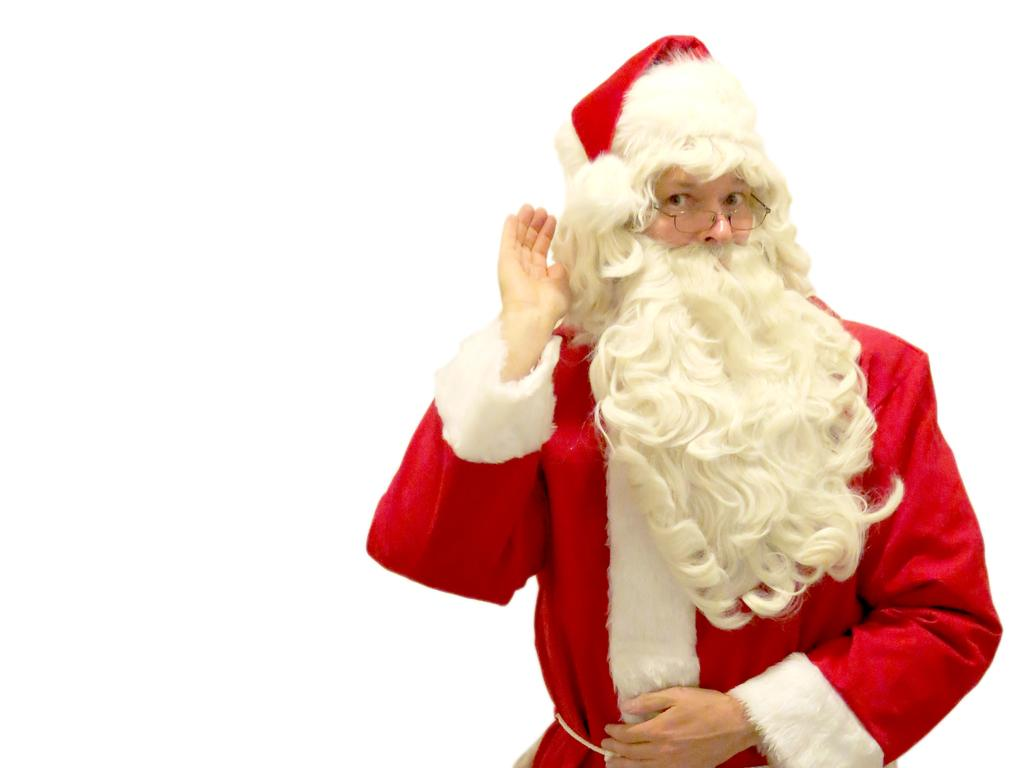What character is depicted in the image? There is a Santa Claus in the image. What accessory is Santa Claus wearing? The Santa Claus is wearing spectacles. What color is the background of the image? The background of the image is white. How many cows can be seen in the image? There are no cows present in the image. What type of trousers is Santa Claus wearing in the image? The provided facts do not mention the type of trousers Santa Claus is wearing in the image. 